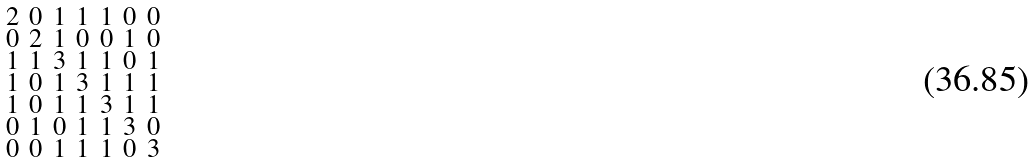<formula> <loc_0><loc_0><loc_500><loc_500>\begin{smallmatrix} 2 & 0 & 1 & 1 & 1 & 0 & 0 \\ 0 & 2 & 1 & 0 & 0 & 1 & 0 \\ 1 & 1 & 3 & 1 & 1 & 0 & 1 \\ 1 & 0 & 1 & 3 & 1 & 1 & 1 \\ 1 & 0 & 1 & 1 & 3 & 1 & 1 \\ 0 & 1 & 0 & 1 & 1 & 3 & 0 \\ 0 & 0 & 1 & 1 & 1 & 0 & 3 \end{smallmatrix}</formula> 